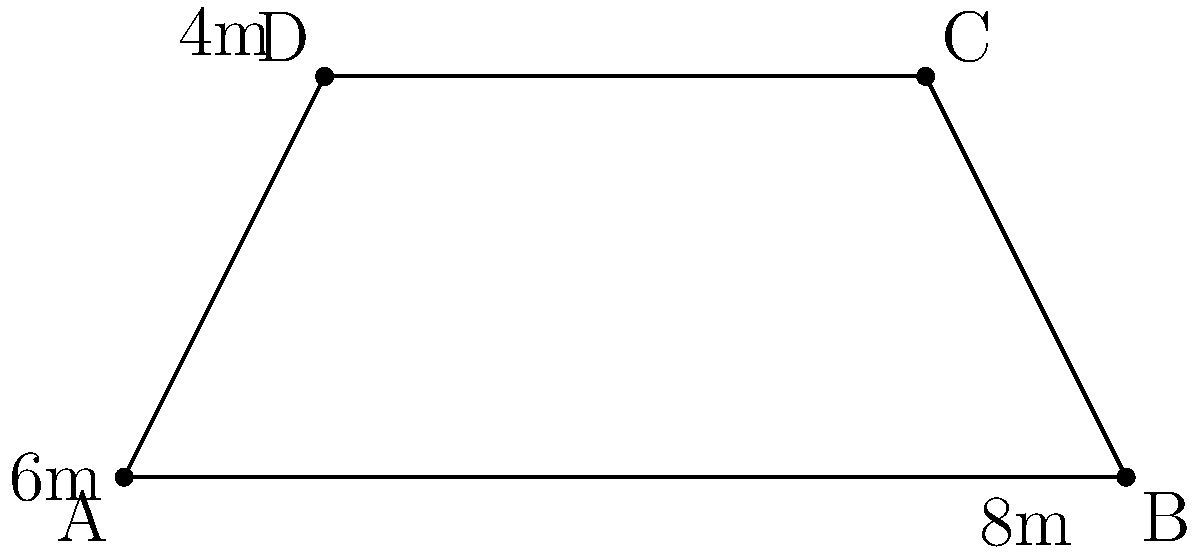You've started a pressure washing side hustle in Brighton to earn some extra cash. A potential client asks you to clean their trapezoidal driveway. The driveway measures 8m at its widest point, 6m at its narrowest point, and has a depth of 4m. Calculate the total area of the driveway to determine how much to charge for the job. To find the area of a trapezoid, we use the formula:

$$A = \frac{1}{2}(a+b)h$$

Where:
$A$ = Area
$a$ = Length of one parallel side
$b$ = Length of the other parallel side
$h$ = Height (perpendicular distance between the parallel sides)

Given:
$a = 8$ m (widest point)
$b = 6$ m (narrowest point)
$h = 4$ m (depth)

Let's substitute these values into the formula:

$$A = \frac{1}{2}(8+6) \times 4$$

$$A = \frac{1}{2}(14) \times 4$$

$$A = 7 \times 4$$

$$A = 28$$

Therefore, the total area of the trapezoidal driveway is 28 square meters.
Answer: 28 m² 